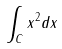<formula> <loc_0><loc_0><loc_500><loc_500>\int _ { C } x ^ { 2 } d x</formula> 